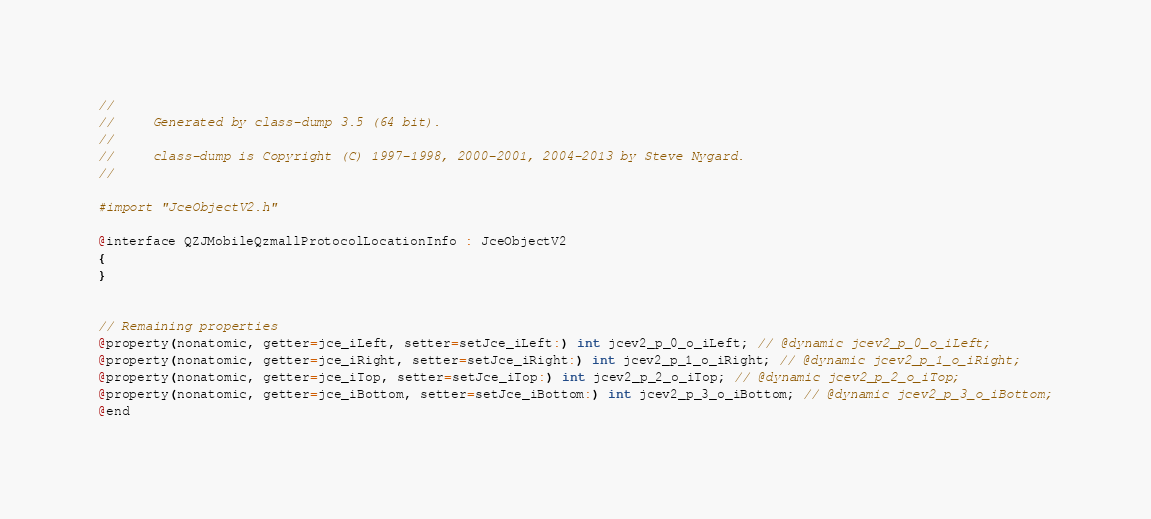<code> <loc_0><loc_0><loc_500><loc_500><_C_>//
//     Generated by class-dump 3.5 (64 bit).
//
//     class-dump is Copyright (C) 1997-1998, 2000-2001, 2004-2013 by Steve Nygard.
//

#import "JceObjectV2.h"

@interface QZJMobileQzmallProtocolLocationInfo : JceObjectV2
{
}


// Remaining properties
@property(nonatomic, getter=jce_iLeft, setter=setJce_iLeft:) int jcev2_p_0_o_iLeft; // @dynamic jcev2_p_0_o_iLeft;
@property(nonatomic, getter=jce_iRight, setter=setJce_iRight:) int jcev2_p_1_o_iRight; // @dynamic jcev2_p_1_o_iRight;
@property(nonatomic, getter=jce_iTop, setter=setJce_iTop:) int jcev2_p_2_o_iTop; // @dynamic jcev2_p_2_o_iTop;
@property(nonatomic, getter=jce_iBottom, setter=setJce_iBottom:) int jcev2_p_3_o_iBottom; // @dynamic jcev2_p_3_o_iBottom;
@end

</code> 